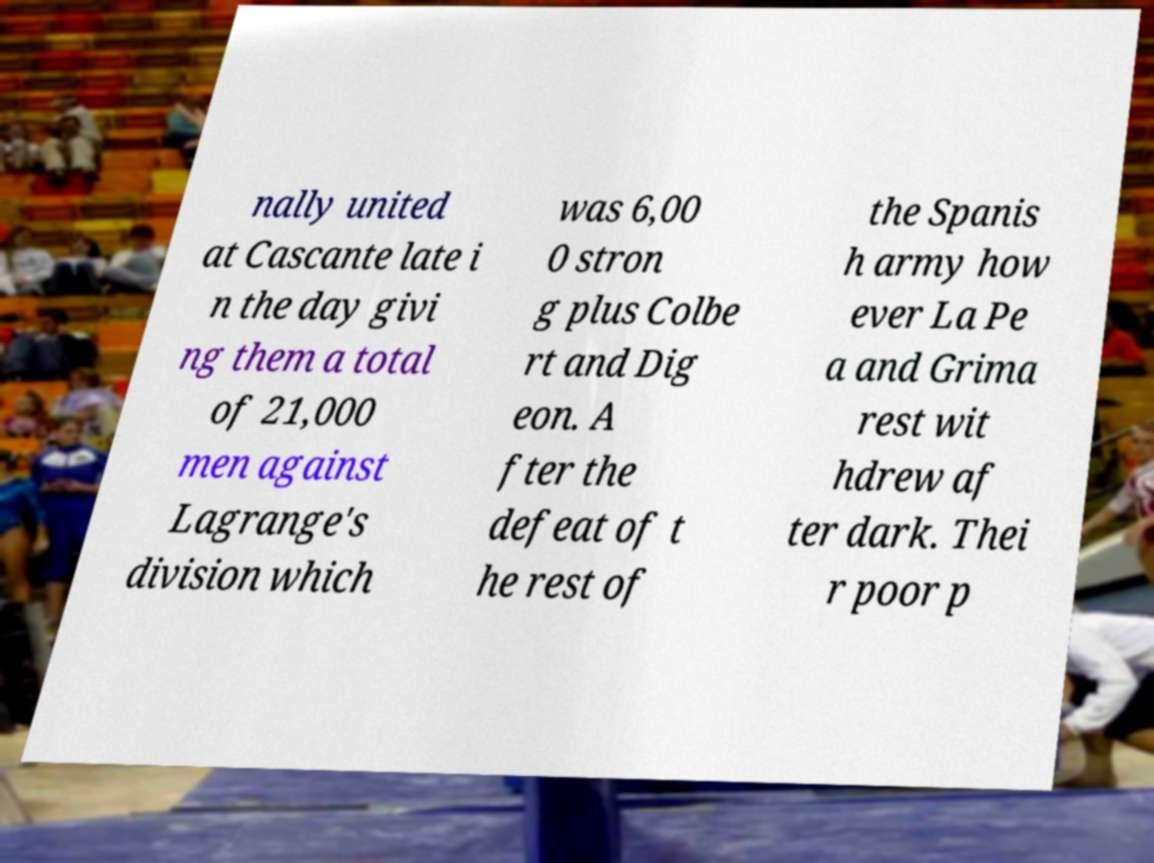Please read and relay the text visible in this image. What does it say? nally united at Cascante late i n the day givi ng them a total of 21,000 men against Lagrange's division which was 6,00 0 stron g plus Colbe rt and Dig eon. A fter the defeat of t he rest of the Spanis h army how ever La Pe a and Grima rest wit hdrew af ter dark. Thei r poor p 